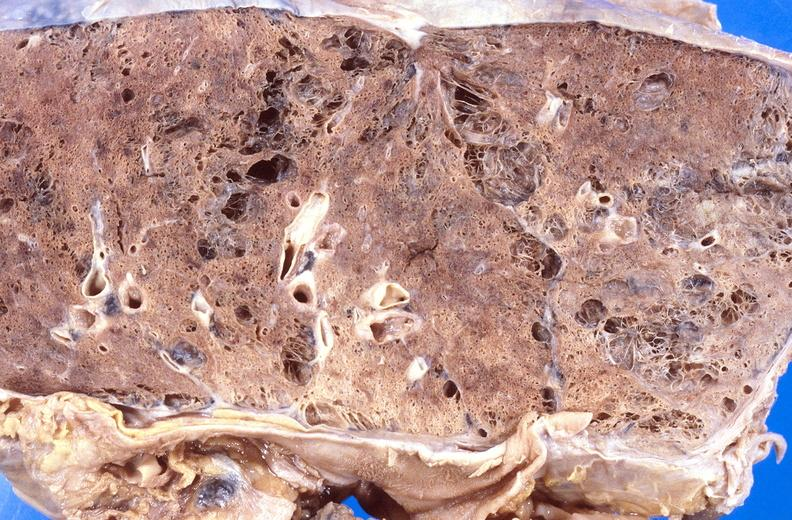s respiratory present?
Answer the question using a single word or phrase. Yes 